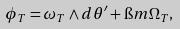Convert formula to latex. <formula><loc_0><loc_0><loc_500><loc_500>\phi _ { T } = \omega _ { T } \wedge d \theta ^ { \prime } + \i m \Omega _ { T } ,</formula> 